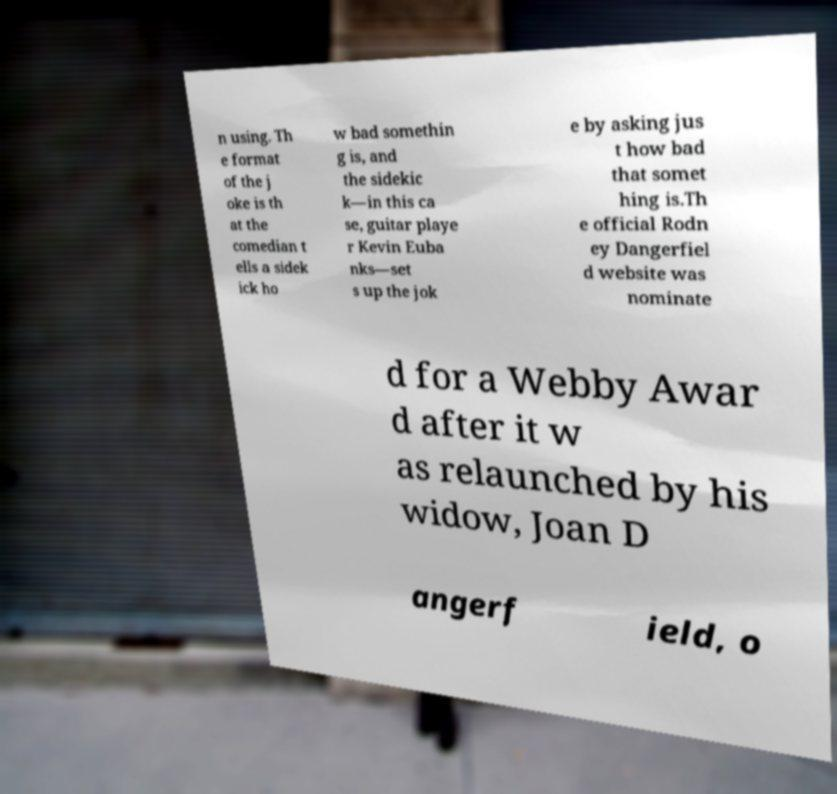I need the written content from this picture converted into text. Can you do that? n using. Th e format of the j oke is th at the comedian t ells a sidek ick ho w bad somethin g is, and the sidekic k—in this ca se, guitar playe r Kevin Euba nks—set s up the jok e by asking jus t how bad that somet hing is.Th e official Rodn ey Dangerfiel d website was nominate d for a Webby Awar d after it w as relaunched by his widow, Joan D angerf ield, o 